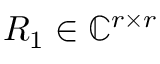<formula> <loc_0><loc_0><loc_500><loc_500>R _ { 1 } \in \mathbb { C } ^ { r \times r }</formula> 